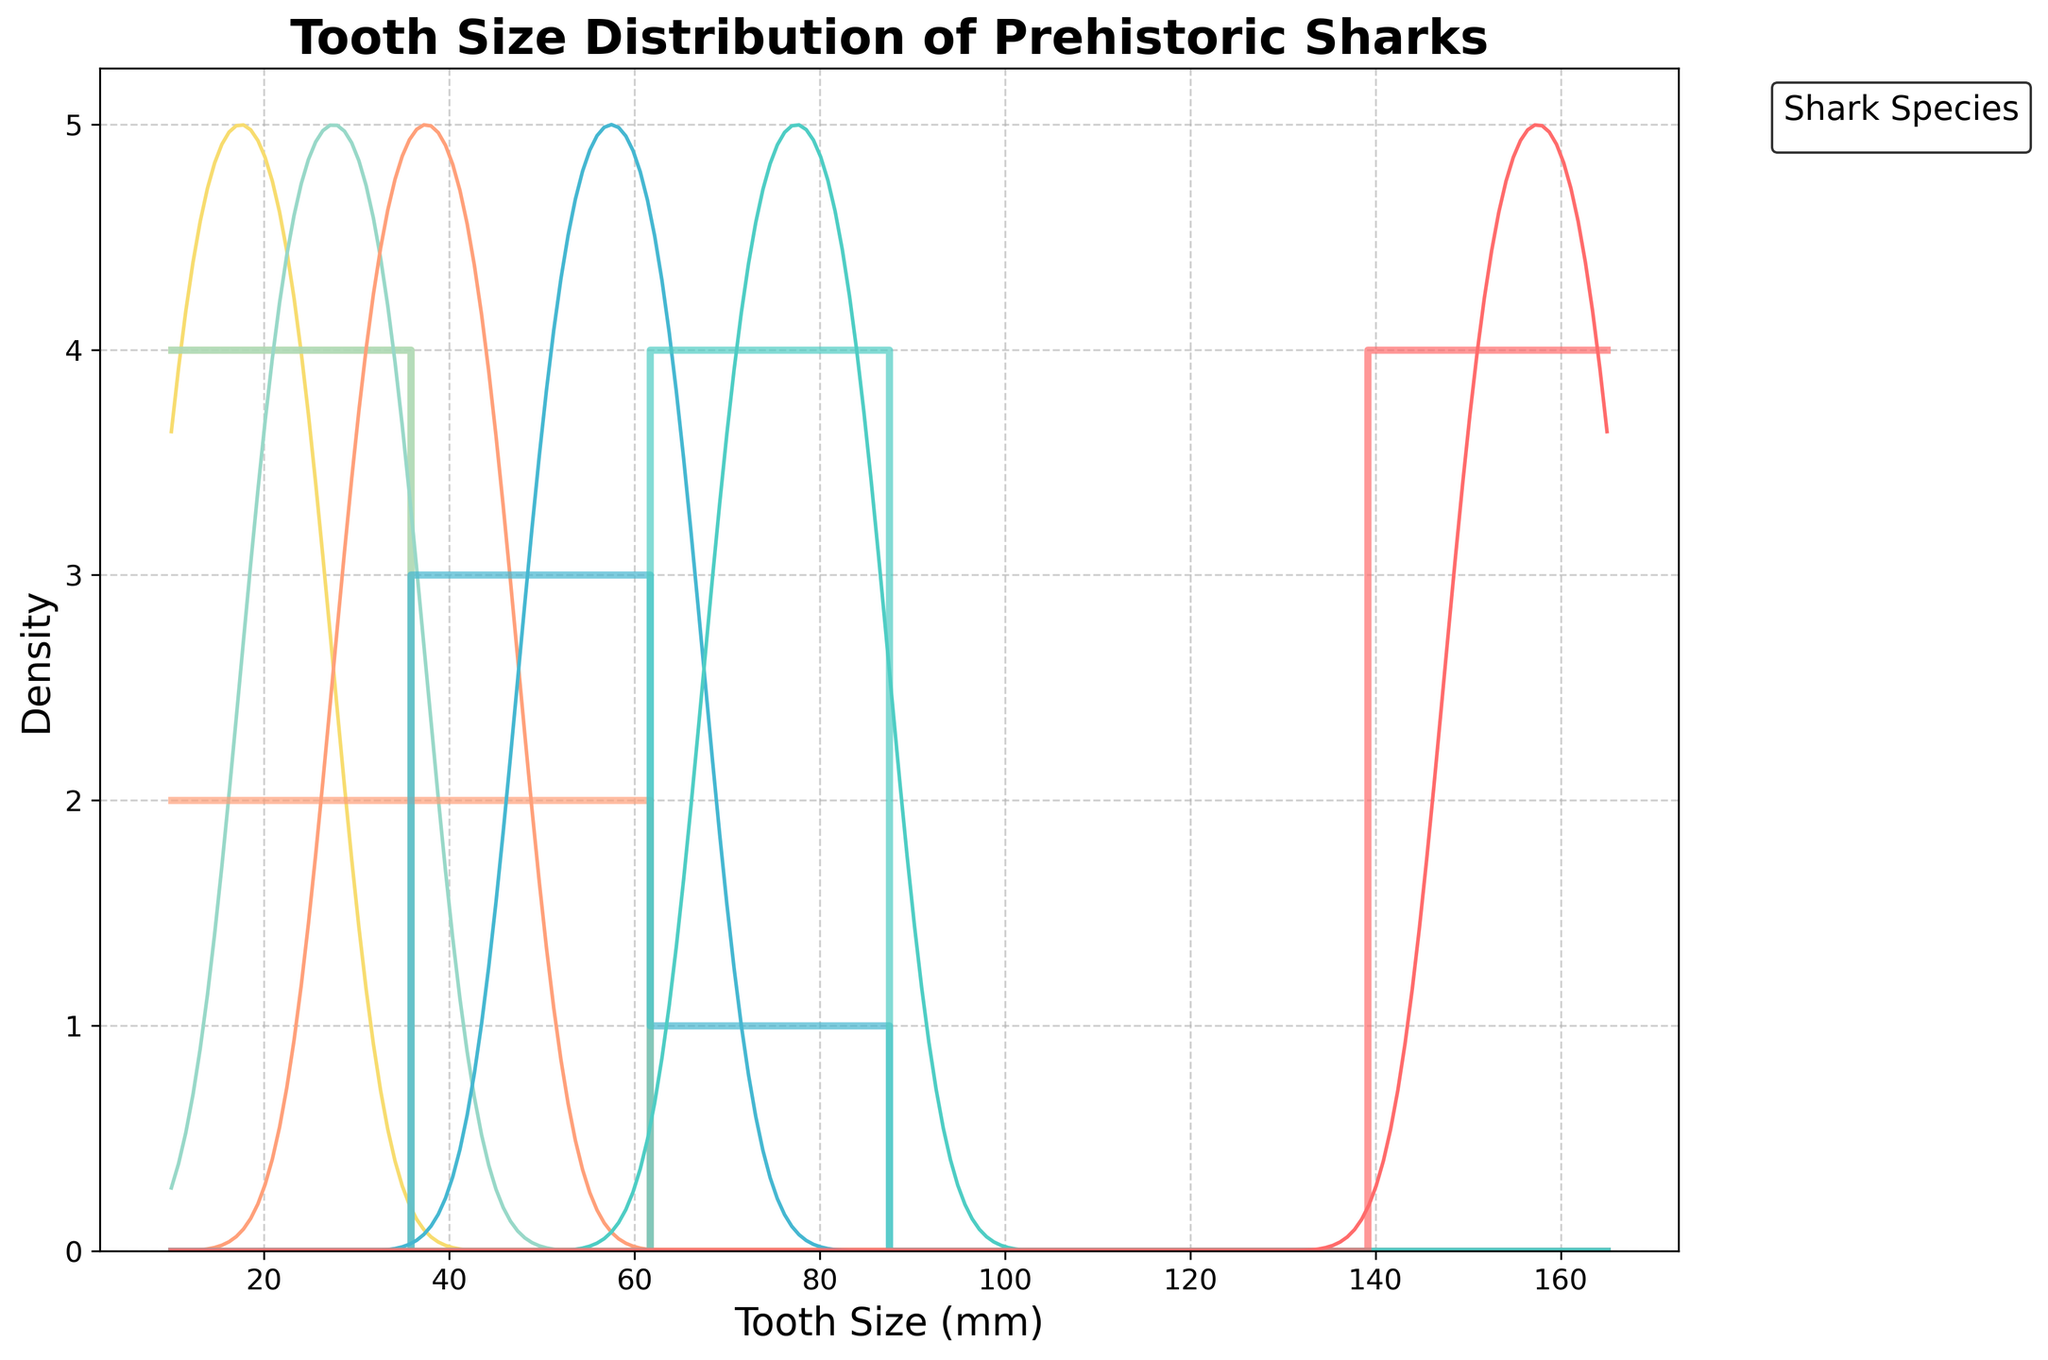what is the title of the plot? The title is located at the top of the plot in a larger and bolded font compared to the rest of the text. The title provides an overall description of what the plot represents. From the description, the title is "Tooth Size Distribution of Prehistoric Sharks".
Answer: Tooth Size Distribution of Prehistoric Sharks how many shark species are being compared in this plot? The number of unique colors in the legend represents the number of different shark species being compared. Each color corresponds to a different shark species. From the code, there are six species being compared.
Answer: Six which shark species has the largest tooth sizes in this plot? Look at the x-axis, which represents tooth size, and find the species whose density curve peaks at the highest values. The description mentions Megalodon, which peaks around 150-165 mm.
Answer: Megalodon do any shark species have overlapping tooth size ranges? By observing the KDE curves and histograms, you can see if different shark species have density curves overlapping in certain ranges on the x-axis. For instance, Otodus obliquus and Megalodon overlap slightly around 70-85 mm.
Answer: Yes which shark species has the smallest tooth sizes according to the plot? Identify the tooth size ranges from the x-axis and find the species whose density curve peaks at the lowest values. According to the description, Hybodus peaks around 10-25 mm.
Answer: Hybodus how does the tooth size of Helicoprion compare to Cretoxyrhina mantelli? Compare the ranges and peaks of their KDE curves. Helicoprion has its tooth size within 30-45 mm while Cretoxyrhina mantelli ranges from 50-65 mm, indicating Helicoprion has generally smaller tooth sizes.
Answer: Helicoprion has smaller teeth within what range do most of Ptychodus mortoni's tooth sizes fall? Observe the KDE curve for Ptychodus mortoni and note the interval on the x-axis where this curve has significant density. For Ptychodus mortoni, this is between 20 and 35 mm.
Answer: 20-35 mm 